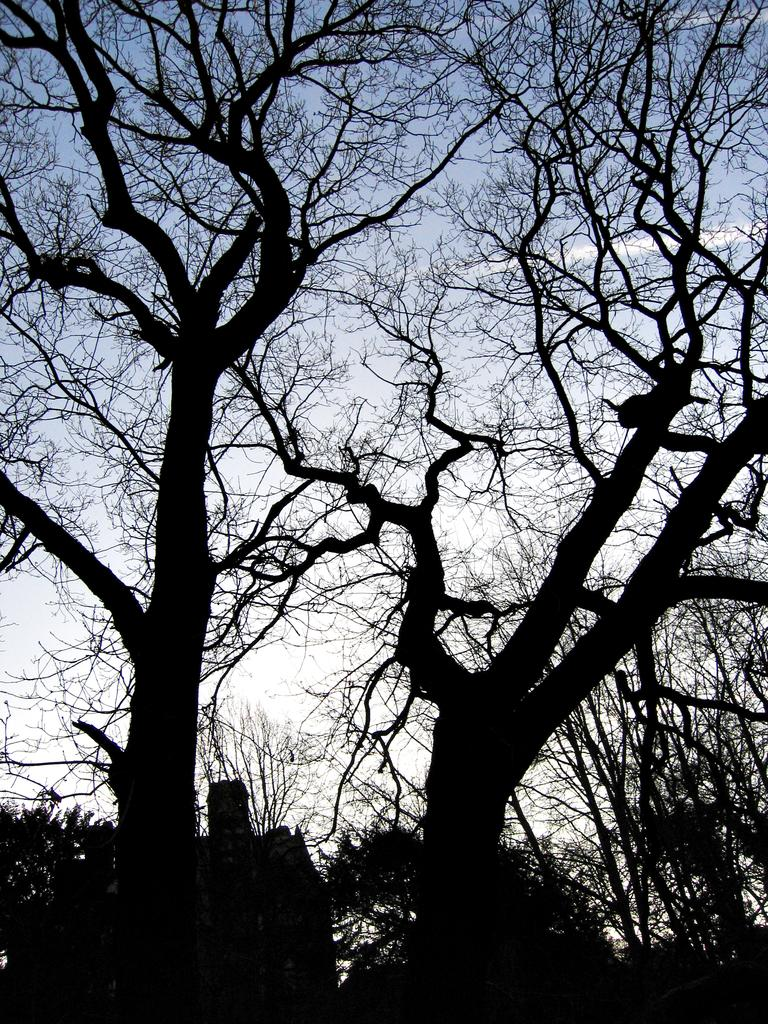What is located in the middle of the image? There are trees in the middle of the image. What can be seen in the sky behind the trees? There are clouds visible in the sky behind the trees. How much money is being exchanged between the trees in the image? There is no money being exchanged in the image, as it features trees and clouds in the sky. 